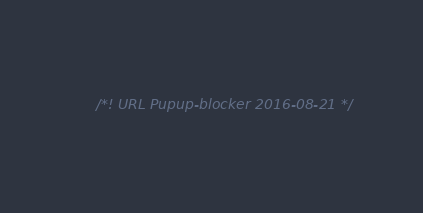Convert code to text. <code><loc_0><loc_0><loc_500><loc_500><_JavaScript_>/*! URL Pupup-blocker 2016-08-21 */</code> 